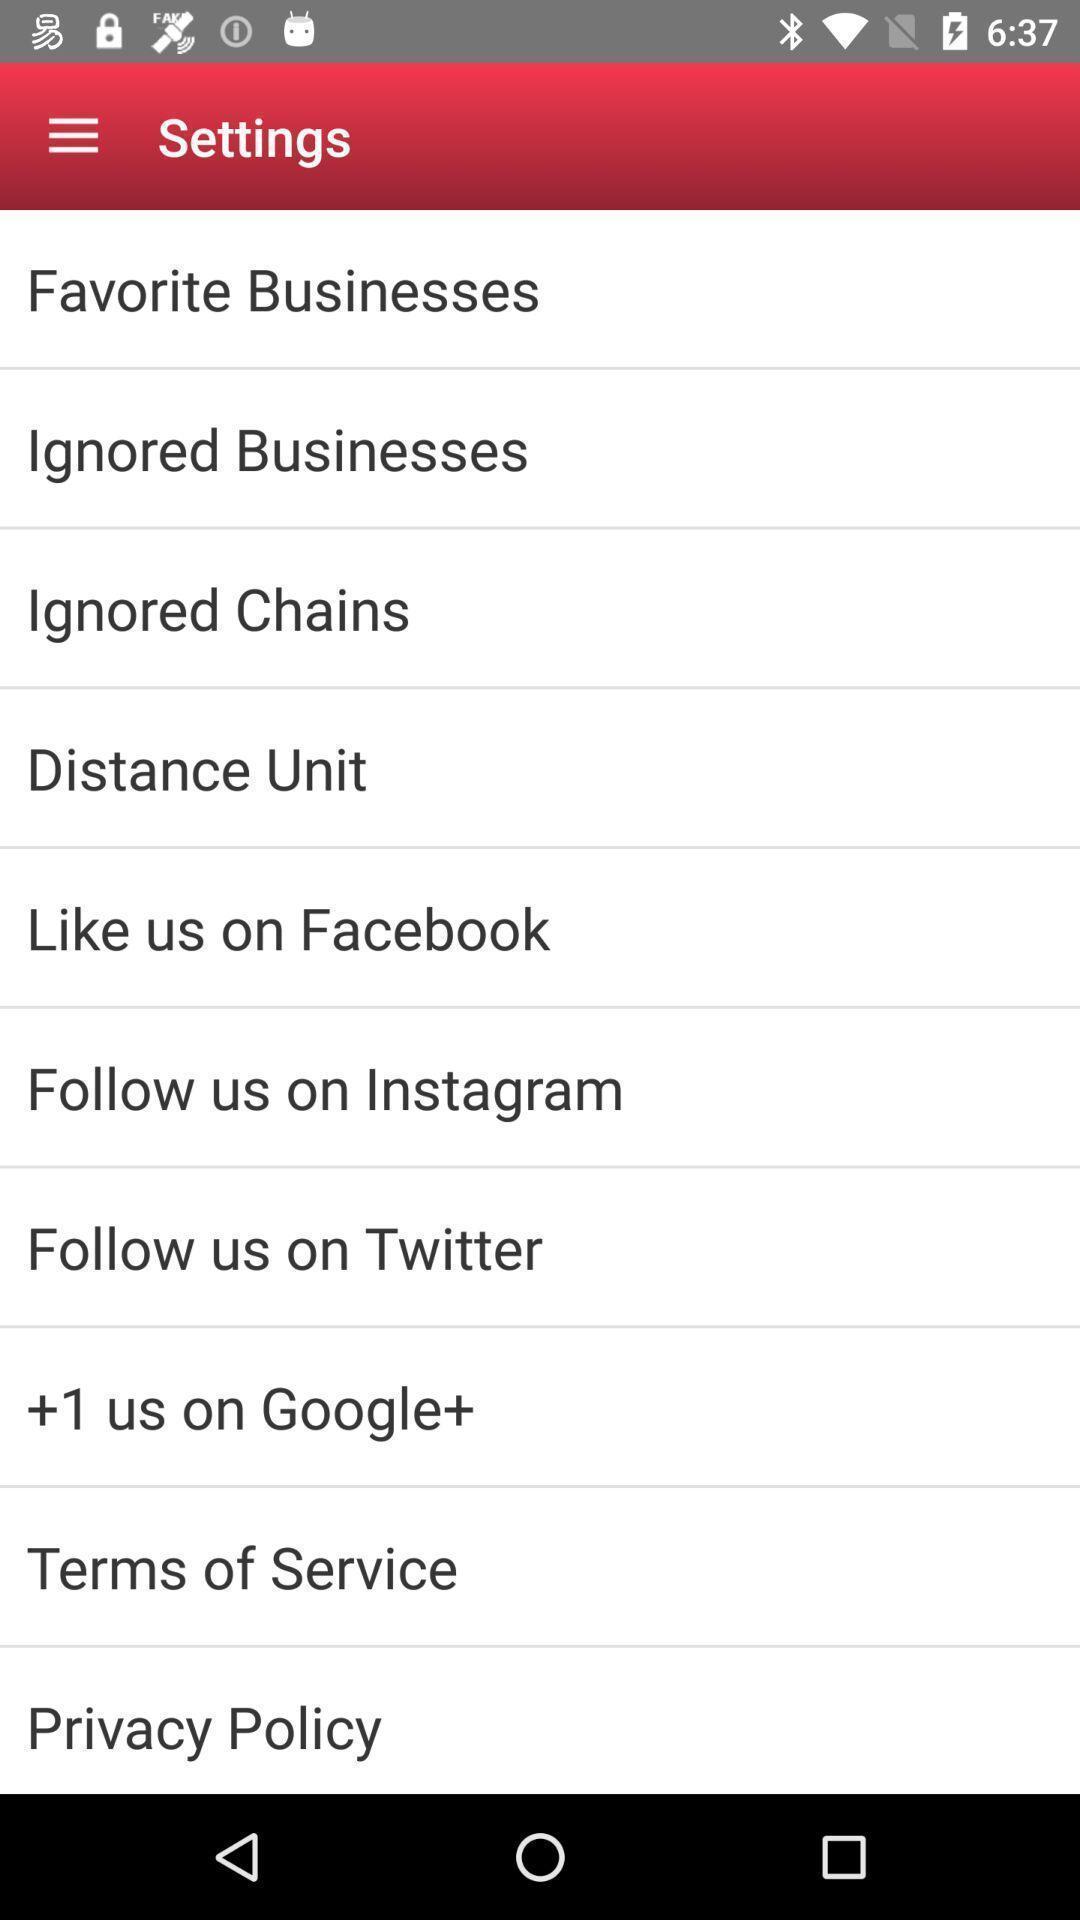Describe the content in this image. Screen shows about settings on an android. 